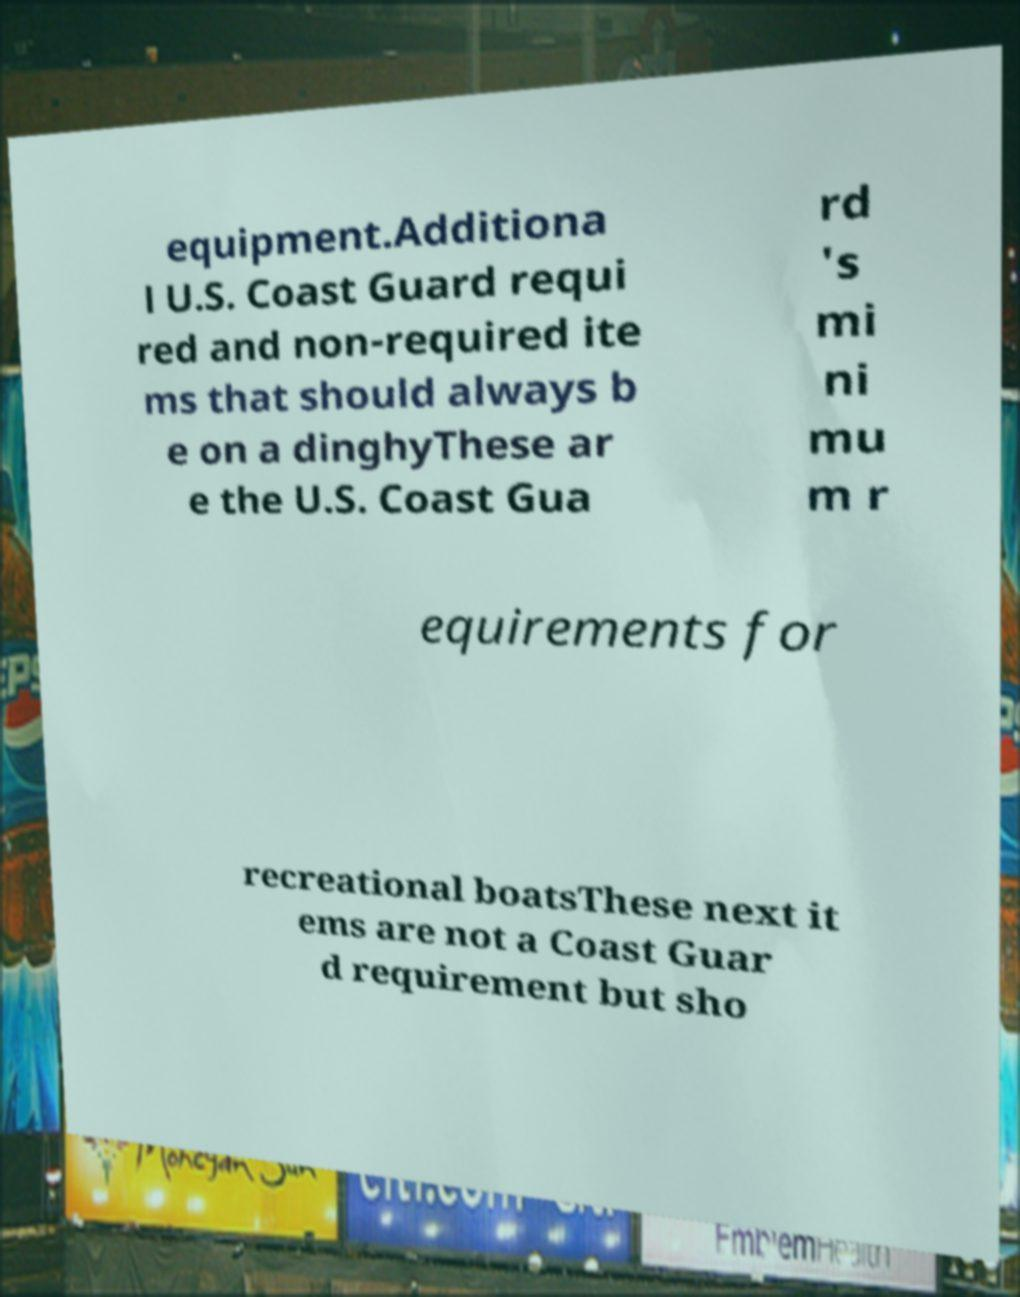For documentation purposes, I need the text within this image transcribed. Could you provide that? equipment.Additiona l U.S. Coast Guard requi red and non-required ite ms that should always b e on a dinghyThese ar e the U.S. Coast Gua rd 's mi ni mu m r equirements for recreational boatsThese next it ems are not a Coast Guar d requirement but sho 